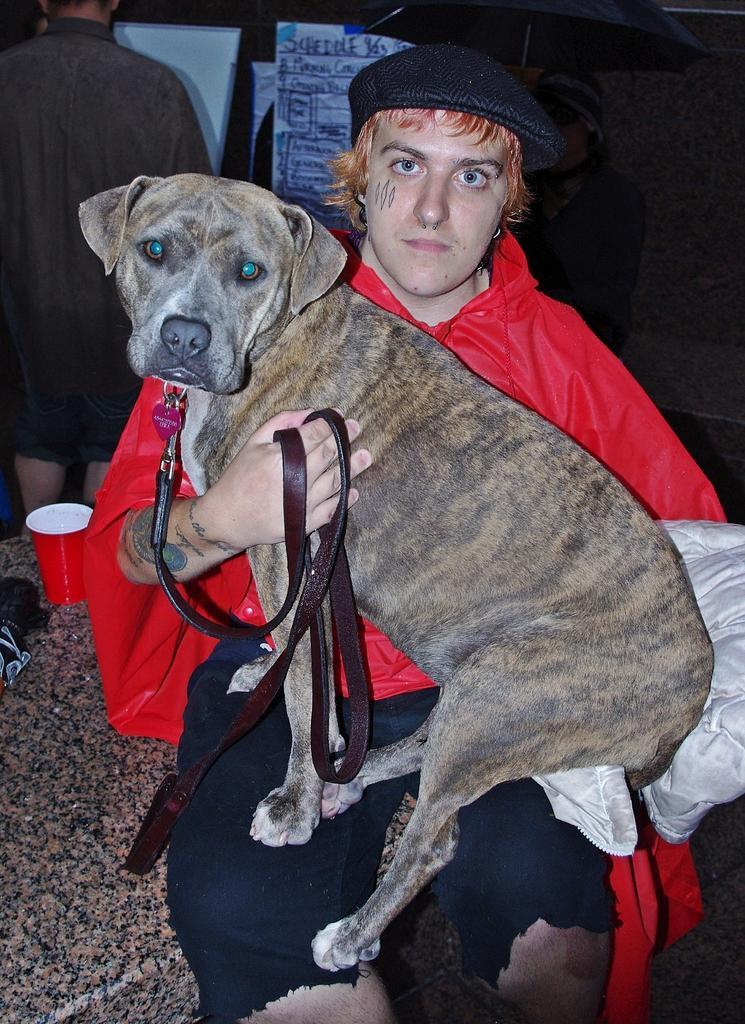How would you summarize this image in a sentence or two? a person is sitting and watching a dog with his hand there is a glass near to him. 